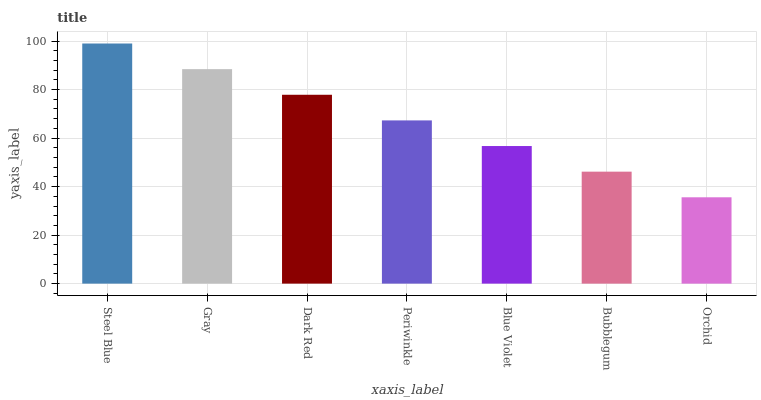Is Orchid the minimum?
Answer yes or no. Yes. Is Steel Blue the maximum?
Answer yes or no. Yes. Is Gray the minimum?
Answer yes or no. No. Is Gray the maximum?
Answer yes or no. No. Is Steel Blue greater than Gray?
Answer yes or no. Yes. Is Gray less than Steel Blue?
Answer yes or no. Yes. Is Gray greater than Steel Blue?
Answer yes or no. No. Is Steel Blue less than Gray?
Answer yes or no. No. Is Periwinkle the high median?
Answer yes or no. Yes. Is Periwinkle the low median?
Answer yes or no. Yes. Is Blue Violet the high median?
Answer yes or no. No. Is Orchid the low median?
Answer yes or no. No. 